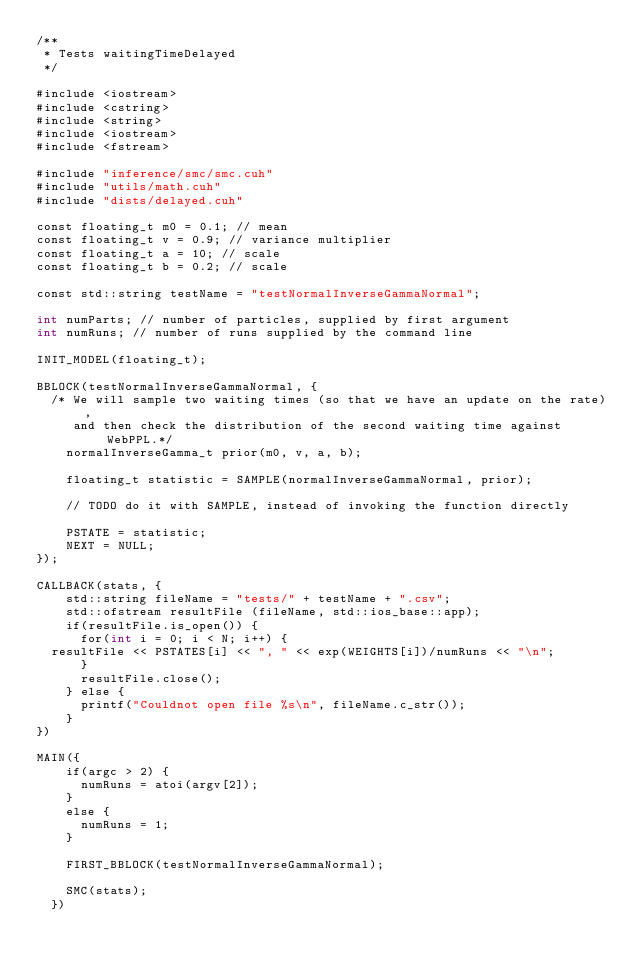Convert code to text. <code><loc_0><loc_0><loc_500><loc_500><_Cuda_>/**
 * Tests waitingTimeDelayed
 */

#include <iostream>
#include <cstring>
#include <string>
#include <iostream>
#include <fstream>

#include "inference/smc/smc.cuh"
#include "utils/math.cuh"
#include "dists/delayed.cuh"

const floating_t m0 = 0.1; // mean
const floating_t v = 0.9; // variance multiplier
const floating_t a = 10; // scale
const floating_t b = 0.2; // scale

const std::string testName = "testNormalInverseGammaNormal";

int numParts; // number of particles, supplied by first argument
int numRuns; // number of runs supplied by the command line

INIT_MODEL(floating_t);

BBLOCK(testNormalInverseGammaNormal, {
  /* We will sample two waiting times (so that we have an update on the rate),
     and then check the distribution of the second waiting time against WebPPL.*/
    normalInverseGamma_t prior(m0, v, a, b);
    
    floating_t statistic = SAMPLE(normalInverseGammaNormal, prior);
  
    // TODO do it with SAMPLE, instead of invoking the function directly
       
    PSTATE = statistic;
    NEXT = NULL;
});

CALLBACK(stats, {
    std::string fileName = "tests/" + testName + ".csv";
    std::ofstream resultFile (fileName, std::ios_base::app);
    if(resultFile.is_open()) {
      for(int i = 0; i < N; i++) {
	resultFile << PSTATES[i] << ", " << exp(WEIGHTS[i])/numRuns << "\n";
      }
      resultFile.close();
    } else {
      printf("Couldnot open file %s\n", fileName.c_str());
    }
})

MAIN({
    if(argc > 2) { 
      numRuns = atoi(argv[2]);			
    }
    else {
      numRuns = 1;
    }
    
    FIRST_BBLOCK(testNormalInverseGammaNormal);
  
    SMC(stats);
  })
</code> 